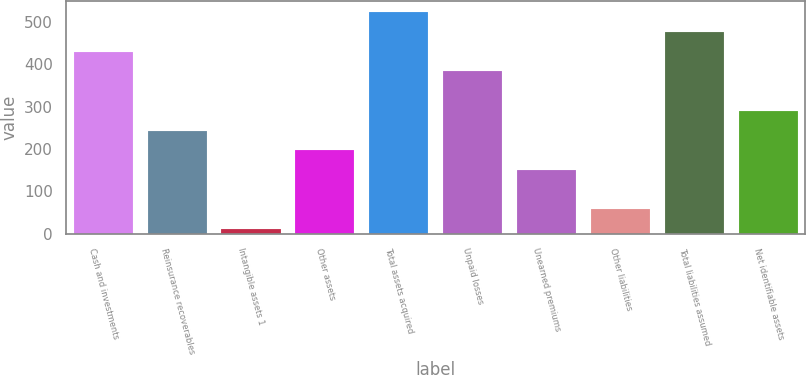Convert chart to OTSL. <chart><loc_0><loc_0><loc_500><loc_500><bar_chart><fcel>Cash and investments<fcel>Reinsurance recoverables<fcel>Intangible assets 1<fcel>Other assets<fcel>Total assets acquired<fcel>Unpaid losses<fcel>Unearned premiums<fcel>Other liabilities<fcel>Total liabilities assumed<fcel>Net identifiable assets<nl><fcel>430.4<fcel>244<fcel>11<fcel>197.4<fcel>523.6<fcel>383.8<fcel>150.8<fcel>57.6<fcel>477<fcel>290.6<nl></chart> 